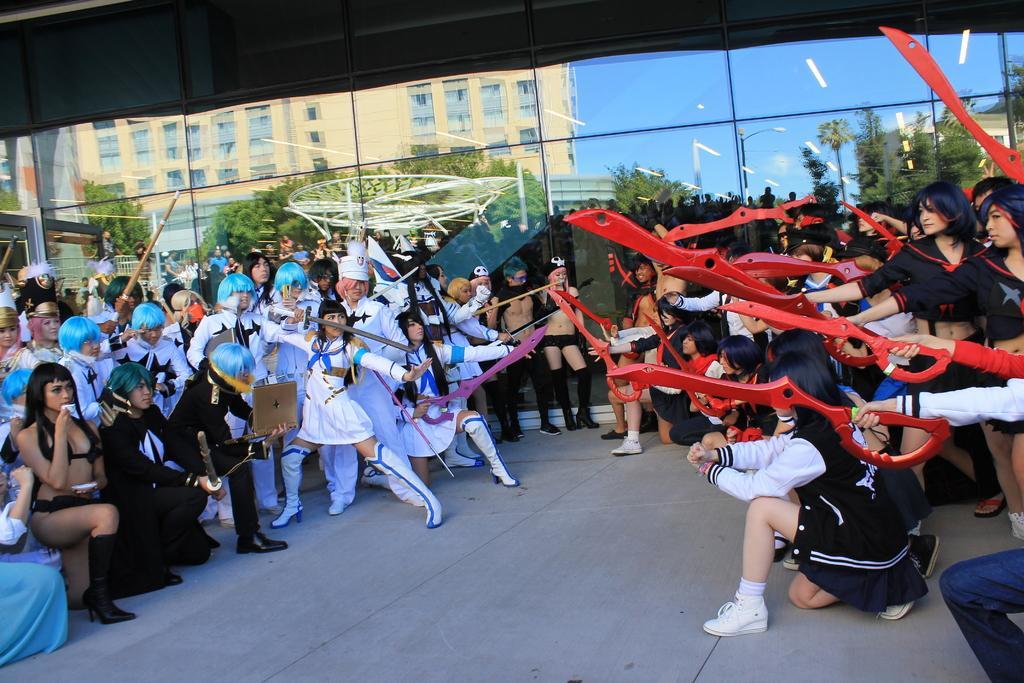Describe this image in one or two sentences. This picture describes about group of people, few people are holding an objects in their hands, beside to them we can see a glass, in the reflection we can find few buildings, trees and poles. 